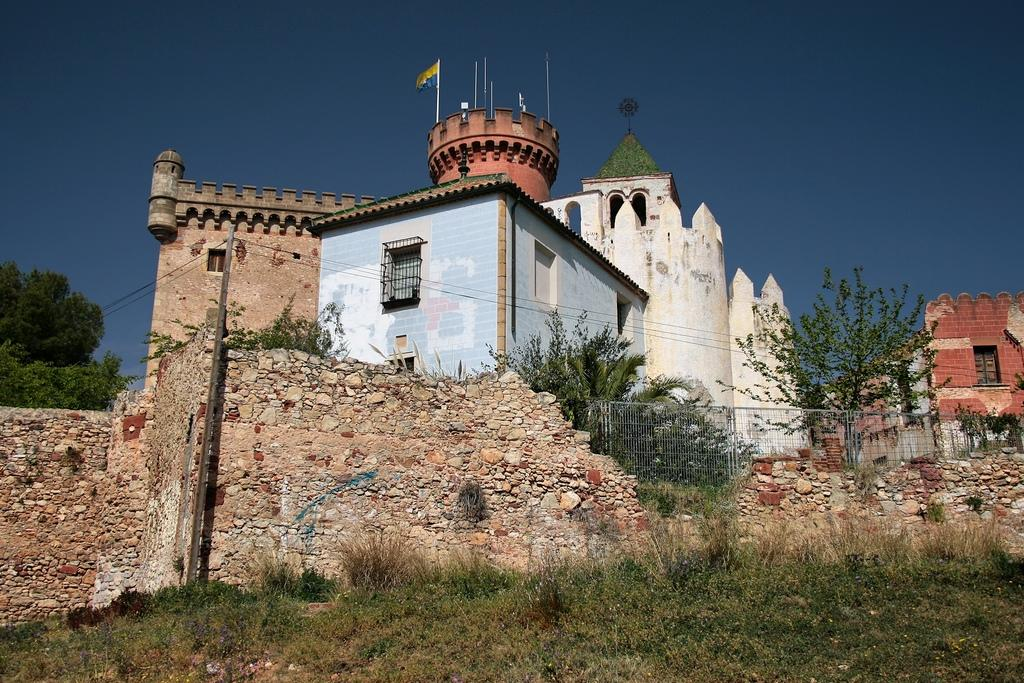What is the main subject in the center of the image? There is a building in the center of the image. Are there any other buildings visible in the image? Yes, there is another building on the right side of the image. What type of vegetation is on the left side of the image? There are trees on the left side of the image. How many pairs of shoes are visible in the image? There are no shoes present in the image. What type of adjustment can be made to the trees on the left side of the image? There is no mention of adjustments or any need for adjustments in the image; the trees are simply present. 